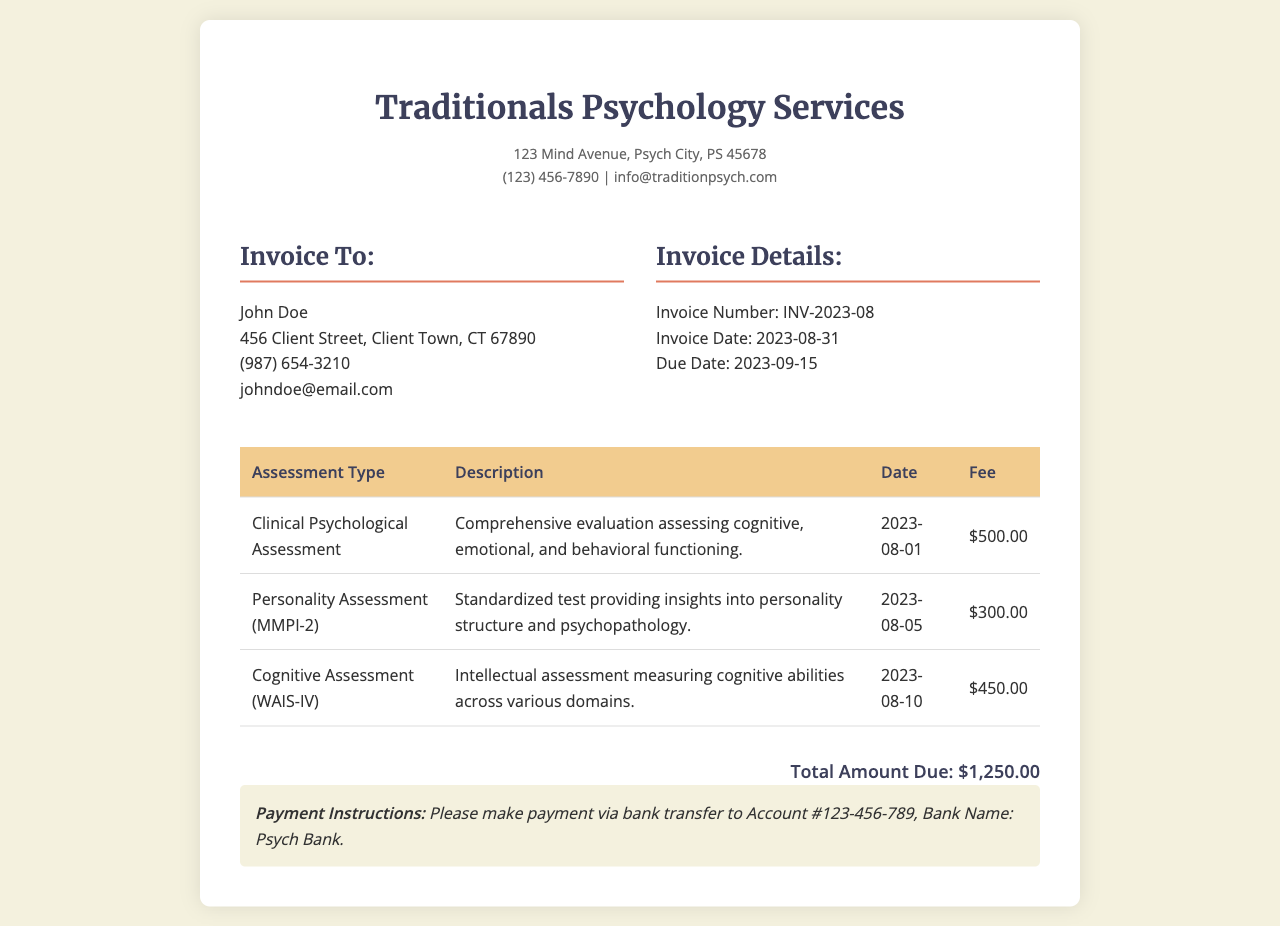What is the invoice number? The invoice number is a unique identifier for this document, which is stated in the invoice details.
Answer: INV-2023-08 Who is the client? The client is the individual to whom the invoice is addressed, provided at the top of the document.
Answer: John Doe What is the total amount due? The total amount due is calculated based on the fees for the assessments listed in the table.
Answer: $1,250.00 What type of assessment was conducted on August 1, 2023? The type of assessment can be found in the table under the date column, indicating the specific service provided on that date.
Answer: Clinical Psychological Assessment How many types of assessments are listed? This requires counting the unique types of assessments mentioned in the table to determine how many were conducted.
Answer: 3 What payment method is specified in the instructions? The payment instructions detail how the client should remit payment, which can be found at the bottom of the invoice.
Answer: Bank transfer What is the due date for this invoice? The due date is provided in the invoice details and indicates when payment should be completed.
Answer: 2023-09-15 What is the date of the personality assessment? The date of the personality assessment can be found in the table next to the corresponding assessment type.
Answer: 2023-08-05 What type of assessment is the WAIS-IV? The WAIS-IV is identified in the table and sought for specific information concerning its categorization.
Answer: Cognitive Assessment 